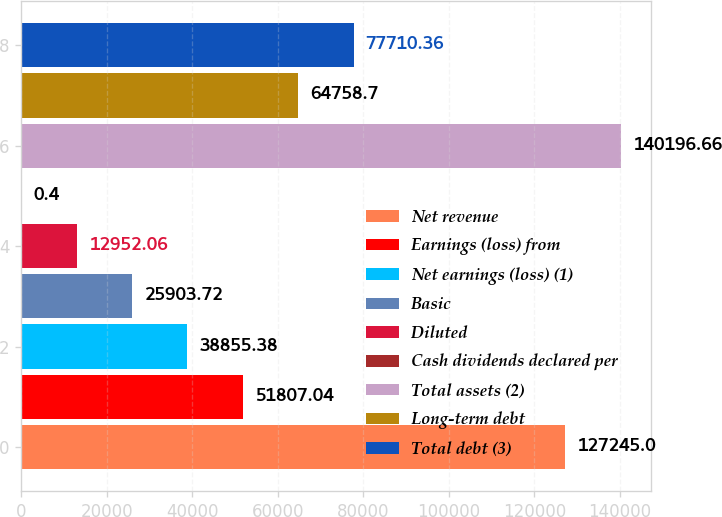Convert chart. <chart><loc_0><loc_0><loc_500><loc_500><bar_chart><fcel>Net revenue<fcel>Earnings (loss) from<fcel>Net earnings (loss) (1)<fcel>Basic<fcel>Diluted<fcel>Cash dividends declared per<fcel>Total assets (2)<fcel>Long-term debt<fcel>Total debt (3)<nl><fcel>127245<fcel>51807<fcel>38855.4<fcel>25903.7<fcel>12952.1<fcel>0.4<fcel>140197<fcel>64758.7<fcel>77710.4<nl></chart> 